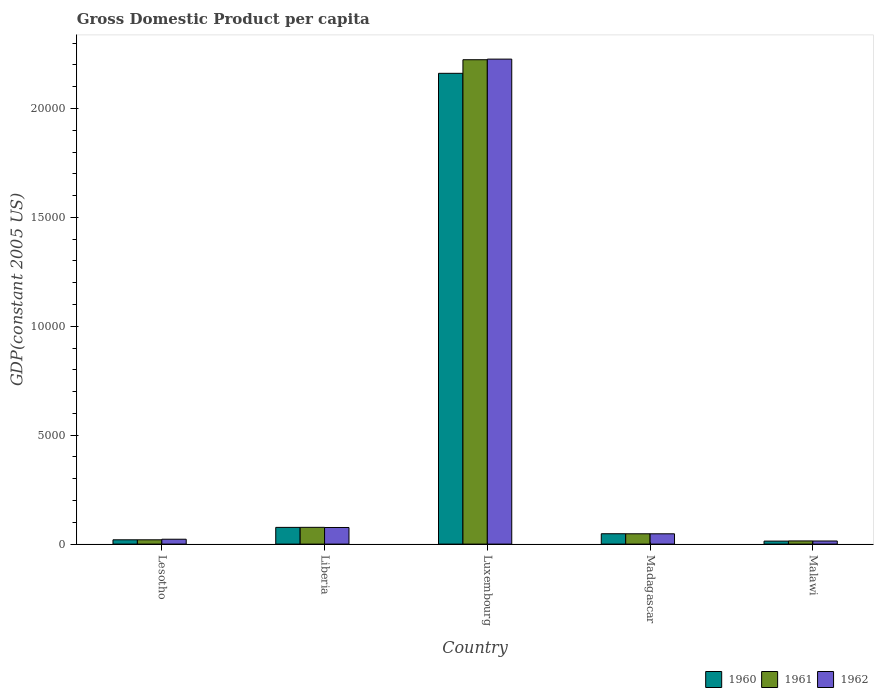How many groups of bars are there?
Ensure brevity in your answer.  5. How many bars are there on the 5th tick from the right?
Offer a terse response. 3. What is the label of the 5th group of bars from the left?
Make the answer very short. Malawi. What is the GDP per capita in 1960 in Malawi?
Offer a very short reply. 138.11. Across all countries, what is the maximum GDP per capita in 1962?
Ensure brevity in your answer.  2.23e+04. Across all countries, what is the minimum GDP per capita in 1960?
Ensure brevity in your answer.  138.11. In which country was the GDP per capita in 1961 maximum?
Your answer should be compact. Luxembourg. In which country was the GDP per capita in 1962 minimum?
Provide a short and direct response. Malawi. What is the total GDP per capita in 1962 in the graph?
Your answer should be very brief. 2.39e+04. What is the difference between the GDP per capita in 1962 in Lesotho and that in Madagascar?
Provide a short and direct response. -248.91. What is the difference between the GDP per capita in 1962 in Lesotho and the GDP per capita in 1961 in Madagascar?
Make the answer very short. -249.83. What is the average GDP per capita in 1962 per country?
Your answer should be compact. 4773.62. What is the difference between the GDP per capita of/in 1961 and GDP per capita of/in 1962 in Madagascar?
Your answer should be very brief. 0.92. In how many countries, is the GDP per capita in 1961 greater than 18000 US$?
Ensure brevity in your answer.  1. What is the ratio of the GDP per capita in 1962 in Madagascar to that in Malawi?
Ensure brevity in your answer.  3.3. Is the difference between the GDP per capita in 1961 in Liberia and Luxembourg greater than the difference between the GDP per capita in 1962 in Liberia and Luxembourg?
Ensure brevity in your answer.  Yes. What is the difference between the highest and the second highest GDP per capita in 1960?
Your answer should be compact. -2.11e+04. What is the difference between the highest and the lowest GDP per capita in 1960?
Ensure brevity in your answer.  2.15e+04. Is the sum of the GDP per capita in 1961 in Liberia and Madagascar greater than the maximum GDP per capita in 1962 across all countries?
Your answer should be very brief. No. Is it the case that in every country, the sum of the GDP per capita in 1962 and GDP per capita in 1960 is greater than the GDP per capita in 1961?
Your response must be concise. Yes. How many countries are there in the graph?
Offer a terse response. 5. Where does the legend appear in the graph?
Keep it short and to the point. Bottom right. How are the legend labels stacked?
Keep it short and to the point. Horizontal. What is the title of the graph?
Ensure brevity in your answer.  Gross Domestic Product per capita. What is the label or title of the Y-axis?
Offer a very short reply. GDP(constant 2005 US). What is the GDP(constant 2005 US) in 1960 in Lesotho?
Your answer should be very brief. 197.38. What is the GDP(constant 2005 US) of 1961 in Lesotho?
Ensure brevity in your answer.  197.61. What is the GDP(constant 2005 US) in 1962 in Lesotho?
Ensure brevity in your answer.  223.86. What is the GDP(constant 2005 US) in 1960 in Liberia?
Offer a very short reply. 767.6. What is the GDP(constant 2005 US) in 1961 in Liberia?
Give a very brief answer. 769.44. What is the GDP(constant 2005 US) in 1962 in Liberia?
Keep it short and to the point. 762.88. What is the GDP(constant 2005 US) of 1960 in Luxembourg?
Your response must be concise. 2.16e+04. What is the GDP(constant 2005 US) in 1961 in Luxembourg?
Your answer should be very brief. 2.22e+04. What is the GDP(constant 2005 US) in 1962 in Luxembourg?
Offer a terse response. 2.23e+04. What is the GDP(constant 2005 US) of 1960 in Madagascar?
Make the answer very short. 475.5. What is the GDP(constant 2005 US) of 1961 in Madagascar?
Provide a short and direct response. 473.7. What is the GDP(constant 2005 US) in 1962 in Madagascar?
Offer a terse response. 472.78. What is the GDP(constant 2005 US) of 1960 in Malawi?
Keep it short and to the point. 138.11. What is the GDP(constant 2005 US) in 1961 in Malawi?
Give a very brief answer. 145.39. What is the GDP(constant 2005 US) in 1962 in Malawi?
Your answer should be compact. 143.1. Across all countries, what is the maximum GDP(constant 2005 US) in 1960?
Offer a very short reply. 2.16e+04. Across all countries, what is the maximum GDP(constant 2005 US) of 1961?
Make the answer very short. 2.22e+04. Across all countries, what is the maximum GDP(constant 2005 US) of 1962?
Provide a short and direct response. 2.23e+04. Across all countries, what is the minimum GDP(constant 2005 US) in 1960?
Offer a terse response. 138.11. Across all countries, what is the minimum GDP(constant 2005 US) of 1961?
Your response must be concise. 145.39. Across all countries, what is the minimum GDP(constant 2005 US) in 1962?
Provide a short and direct response. 143.1. What is the total GDP(constant 2005 US) of 1960 in the graph?
Give a very brief answer. 2.32e+04. What is the total GDP(constant 2005 US) in 1961 in the graph?
Ensure brevity in your answer.  2.38e+04. What is the total GDP(constant 2005 US) of 1962 in the graph?
Ensure brevity in your answer.  2.39e+04. What is the difference between the GDP(constant 2005 US) of 1960 in Lesotho and that in Liberia?
Offer a terse response. -570.22. What is the difference between the GDP(constant 2005 US) of 1961 in Lesotho and that in Liberia?
Offer a terse response. -571.83. What is the difference between the GDP(constant 2005 US) in 1962 in Lesotho and that in Liberia?
Provide a short and direct response. -539.02. What is the difference between the GDP(constant 2005 US) of 1960 in Lesotho and that in Luxembourg?
Your answer should be compact. -2.14e+04. What is the difference between the GDP(constant 2005 US) in 1961 in Lesotho and that in Luxembourg?
Make the answer very short. -2.20e+04. What is the difference between the GDP(constant 2005 US) in 1962 in Lesotho and that in Luxembourg?
Offer a terse response. -2.20e+04. What is the difference between the GDP(constant 2005 US) of 1960 in Lesotho and that in Madagascar?
Make the answer very short. -278.12. What is the difference between the GDP(constant 2005 US) of 1961 in Lesotho and that in Madagascar?
Provide a short and direct response. -276.09. What is the difference between the GDP(constant 2005 US) of 1962 in Lesotho and that in Madagascar?
Offer a terse response. -248.91. What is the difference between the GDP(constant 2005 US) in 1960 in Lesotho and that in Malawi?
Your answer should be very brief. 59.27. What is the difference between the GDP(constant 2005 US) in 1961 in Lesotho and that in Malawi?
Ensure brevity in your answer.  52.22. What is the difference between the GDP(constant 2005 US) in 1962 in Lesotho and that in Malawi?
Offer a terse response. 80.77. What is the difference between the GDP(constant 2005 US) in 1960 in Liberia and that in Luxembourg?
Keep it short and to the point. -2.08e+04. What is the difference between the GDP(constant 2005 US) of 1961 in Liberia and that in Luxembourg?
Ensure brevity in your answer.  -2.15e+04. What is the difference between the GDP(constant 2005 US) in 1962 in Liberia and that in Luxembourg?
Provide a short and direct response. -2.15e+04. What is the difference between the GDP(constant 2005 US) in 1960 in Liberia and that in Madagascar?
Your response must be concise. 292.1. What is the difference between the GDP(constant 2005 US) in 1961 in Liberia and that in Madagascar?
Your answer should be compact. 295.74. What is the difference between the GDP(constant 2005 US) in 1962 in Liberia and that in Madagascar?
Give a very brief answer. 290.11. What is the difference between the GDP(constant 2005 US) in 1960 in Liberia and that in Malawi?
Provide a succinct answer. 629.48. What is the difference between the GDP(constant 2005 US) of 1961 in Liberia and that in Malawi?
Provide a short and direct response. 624.05. What is the difference between the GDP(constant 2005 US) in 1962 in Liberia and that in Malawi?
Your response must be concise. 619.78. What is the difference between the GDP(constant 2005 US) in 1960 in Luxembourg and that in Madagascar?
Your response must be concise. 2.11e+04. What is the difference between the GDP(constant 2005 US) in 1961 in Luxembourg and that in Madagascar?
Provide a succinct answer. 2.18e+04. What is the difference between the GDP(constant 2005 US) in 1962 in Luxembourg and that in Madagascar?
Your response must be concise. 2.18e+04. What is the difference between the GDP(constant 2005 US) of 1960 in Luxembourg and that in Malawi?
Give a very brief answer. 2.15e+04. What is the difference between the GDP(constant 2005 US) in 1961 in Luxembourg and that in Malawi?
Give a very brief answer. 2.21e+04. What is the difference between the GDP(constant 2005 US) of 1962 in Luxembourg and that in Malawi?
Your response must be concise. 2.21e+04. What is the difference between the GDP(constant 2005 US) of 1960 in Madagascar and that in Malawi?
Make the answer very short. 337.39. What is the difference between the GDP(constant 2005 US) of 1961 in Madagascar and that in Malawi?
Your answer should be compact. 328.31. What is the difference between the GDP(constant 2005 US) of 1962 in Madagascar and that in Malawi?
Give a very brief answer. 329.68. What is the difference between the GDP(constant 2005 US) in 1960 in Lesotho and the GDP(constant 2005 US) in 1961 in Liberia?
Provide a short and direct response. -572.07. What is the difference between the GDP(constant 2005 US) of 1960 in Lesotho and the GDP(constant 2005 US) of 1962 in Liberia?
Your response must be concise. -565.51. What is the difference between the GDP(constant 2005 US) of 1961 in Lesotho and the GDP(constant 2005 US) of 1962 in Liberia?
Your answer should be compact. -565.27. What is the difference between the GDP(constant 2005 US) in 1960 in Lesotho and the GDP(constant 2005 US) in 1961 in Luxembourg?
Provide a succinct answer. -2.20e+04. What is the difference between the GDP(constant 2005 US) in 1960 in Lesotho and the GDP(constant 2005 US) in 1962 in Luxembourg?
Keep it short and to the point. -2.21e+04. What is the difference between the GDP(constant 2005 US) of 1961 in Lesotho and the GDP(constant 2005 US) of 1962 in Luxembourg?
Provide a succinct answer. -2.21e+04. What is the difference between the GDP(constant 2005 US) of 1960 in Lesotho and the GDP(constant 2005 US) of 1961 in Madagascar?
Provide a short and direct response. -276.32. What is the difference between the GDP(constant 2005 US) of 1960 in Lesotho and the GDP(constant 2005 US) of 1962 in Madagascar?
Your response must be concise. -275.4. What is the difference between the GDP(constant 2005 US) of 1961 in Lesotho and the GDP(constant 2005 US) of 1962 in Madagascar?
Your response must be concise. -275.16. What is the difference between the GDP(constant 2005 US) of 1960 in Lesotho and the GDP(constant 2005 US) of 1961 in Malawi?
Provide a short and direct response. 51.99. What is the difference between the GDP(constant 2005 US) of 1960 in Lesotho and the GDP(constant 2005 US) of 1962 in Malawi?
Offer a very short reply. 54.28. What is the difference between the GDP(constant 2005 US) of 1961 in Lesotho and the GDP(constant 2005 US) of 1962 in Malawi?
Offer a very short reply. 54.51. What is the difference between the GDP(constant 2005 US) in 1960 in Liberia and the GDP(constant 2005 US) in 1961 in Luxembourg?
Your response must be concise. -2.15e+04. What is the difference between the GDP(constant 2005 US) in 1960 in Liberia and the GDP(constant 2005 US) in 1962 in Luxembourg?
Offer a terse response. -2.15e+04. What is the difference between the GDP(constant 2005 US) of 1961 in Liberia and the GDP(constant 2005 US) of 1962 in Luxembourg?
Your answer should be very brief. -2.15e+04. What is the difference between the GDP(constant 2005 US) of 1960 in Liberia and the GDP(constant 2005 US) of 1961 in Madagascar?
Offer a terse response. 293.9. What is the difference between the GDP(constant 2005 US) of 1960 in Liberia and the GDP(constant 2005 US) of 1962 in Madagascar?
Ensure brevity in your answer.  294.82. What is the difference between the GDP(constant 2005 US) in 1961 in Liberia and the GDP(constant 2005 US) in 1962 in Madagascar?
Provide a succinct answer. 296.67. What is the difference between the GDP(constant 2005 US) of 1960 in Liberia and the GDP(constant 2005 US) of 1961 in Malawi?
Offer a terse response. 622.21. What is the difference between the GDP(constant 2005 US) of 1960 in Liberia and the GDP(constant 2005 US) of 1962 in Malawi?
Your response must be concise. 624.5. What is the difference between the GDP(constant 2005 US) in 1961 in Liberia and the GDP(constant 2005 US) in 1962 in Malawi?
Give a very brief answer. 626.34. What is the difference between the GDP(constant 2005 US) in 1960 in Luxembourg and the GDP(constant 2005 US) in 1961 in Madagascar?
Provide a succinct answer. 2.11e+04. What is the difference between the GDP(constant 2005 US) of 1960 in Luxembourg and the GDP(constant 2005 US) of 1962 in Madagascar?
Give a very brief answer. 2.11e+04. What is the difference between the GDP(constant 2005 US) in 1961 in Luxembourg and the GDP(constant 2005 US) in 1962 in Madagascar?
Make the answer very short. 2.18e+04. What is the difference between the GDP(constant 2005 US) in 1960 in Luxembourg and the GDP(constant 2005 US) in 1961 in Malawi?
Your response must be concise. 2.15e+04. What is the difference between the GDP(constant 2005 US) in 1960 in Luxembourg and the GDP(constant 2005 US) in 1962 in Malawi?
Keep it short and to the point. 2.15e+04. What is the difference between the GDP(constant 2005 US) of 1961 in Luxembourg and the GDP(constant 2005 US) of 1962 in Malawi?
Ensure brevity in your answer.  2.21e+04. What is the difference between the GDP(constant 2005 US) of 1960 in Madagascar and the GDP(constant 2005 US) of 1961 in Malawi?
Offer a very short reply. 330.11. What is the difference between the GDP(constant 2005 US) in 1960 in Madagascar and the GDP(constant 2005 US) in 1962 in Malawi?
Your answer should be very brief. 332.4. What is the difference between the GDP(constant 2005 US) of 1961 in Madagascar and the GDP(constant 2005 US) of 1962 in Malawi?
Offer a terse response. 330.6. What is the average GDP(constant 2005 US) in 1960 per country?
Your response must be concise. 4638.43. What is the average GDP(constant 2005 US) in 1961 per country?
Provide a succinct answer. 4764.78. What is the average GDP(constant 2005 US) of 1962 per country?
Your response must be concise. 4773.62. What is the difference between the GDP(constant 2005 US) of 1960 and GDP(constant 2005 US) of 1961 in Lesotho?
Offer a terse response. -0.24. What is the difference between the GDP(constant 2005 US) of 1960 and GDP(constant 2005 US) of 1962 in Lesotho?
Make the answer very short. -26.49. What is the difference between the GDP(constant 2005 US) in 1961 and GDP(constant 2005 US) in 1962 in Lesotho?
Your response must be concise. -26.25. What is the difference between the GDP(constant 2005 US) in 1960 and GDP(constant 2005 US) in 1961 in Liberia?
Provide a succinct answer. -1.85. What is the difference between the GDP(constant 2005 US) in 1960 and GDP(constant 2005 US) in 1962 in Liberia?
Your answer should be compact. 4.71. What is the difference between the GDP(constant 2005 US) in 1961 and GDP(constant 2005 US) in 1962 in Liberia?
Offer a very short reply. 6.56. What is the difference between the GDP(constant 2005 US) of 1960 and GDP(constant 2005 US) of 1961 in Luxembourg?
Make the answer very short. -624.17. What is the difference between the GDP(constant 2005 US) in 1960 and GDP(constant 2005 US) in 1962 in Luxembourg?
Ensure brevity in your answer.  -651.89. What is the difference between the GDP(constant 2005 US) in 1961 and GDP(constant 2005 US) in 1962 in Luxembourg?
Give a very brief answer. -27.73. What is the difference between the GDP(constant 2005 US) in 1960 and GDP(constant 2005 US) in 1961 in Madagascar?
Provide a succinct answer. 1.8. What is the difference between the GDP(constant 2005 US) in 1960 and GDP(constant 2005 US) in 1962 in Madagascar?
Make the answer very short. 2.72. What is the difference between the GDP(constant 2005 US) of 1961 and GDP(constant 2005 US) of 1962 in Madagascar?
Keep it short and to the point. 0.92. What is the difference between the GDP(constant 2005 US) in 1960 and GDP(constant 2005 US) in 1961 in Malawi?
Provide a succinct answer. -7.28. What is the difference between the GDP(constant 2005 US) in 1960 and GDP(constant 2005 US) in 1962 in Malawi?
Provide a short and direct response. -4.99. What is the difference between the GDP(constant 2005 US) of 1961 and GDP(constant 2005 US) of 1962 in Malawi?
Keep it short and to the point. 2.29. What is the ratio of the GDP(constant 2005 US) of 1960 in Lesotho to that in Liberia?
Your answer should be compact. 0.26. What is the ratio of the GDP(constant 2005 US) in 1961 in Lesotho to that in Liberia?
Give a very brief answer. 0.26. What is the ratio of the GDP(constant 2005 US) of 1962 in Lesotho to that in Liberia?
Offer a terse response. 0.29. What is the ratio of the GDP(constant 2005 US) in 1960 in Lesotho to that in Luxembourg?
Ensure brevity in your answer.  0.01. What is the ratio of the GDP(constant 2005 US) of 1961 in Lesotho to that in Luxembourg?
Provide a succinct answer. 0.01. What is the ratio of the GDP(constant 2005 US) in 1962 in Lesotho to that in Luxembourg?
Make the answer very short. 0.01. What is the ratio of the GDP(constant 2005 US) in 1960 in Lesotho to that in Madagascar?
Give a very brief answer. 0.42. What is the ratio of the GDP(constant 2005 US) in 1961 in Lesotho to that in Madagascar?
Your response must be concise. 0.42. What is the ratio of the GDP(constant 2005 US) of 1962 in Lesotho to that in Madagascar?
Offer a very short reply. 0.47. What is the ratio of the GDP(constant 2005 US) in 1960 in Lesotho to that in Malawi?
Offer a very short reply. 1.43. What is the ratio of the GDP(constant 2005 US) in 1961 in Lesotho to that in Malawi?
Make the answer very short. 1.36. What is the ratio of the GDP(constant 2005 US) in 1962 in Lesotho to that in Malawi?
Offer a very short reply. 1.56. What is the ratio of the GDP(constant 2005 US) of 1960 in Liberia to that in Luxembourg?
Keep it short and to the point. 0.04. What is the ratio of the GDP(constant 2005 US) of 1961 in Liberia to that in Luxembourg?
Your answer should be compact. 0.03. What is the ratio of the GDP(constant 2005 US) of 1962 in Liberia to that in Luxembourg?
Offer a very short reply. 0.03. What is the ratio of the GDP(constant 2005 US) of 1960 in Liberia to that in Madagascar?
Ensure brevity in your answer.  1.61. What is the ratio of the GDP(constant 2005 US) of 1961 in Liberia to that in Madagascar?
Your response must be concise. 1.62. What is the ratio of the GDP(constant 2005 US) in 1962 in Liberia to that in Madagascar?
Make the answer very short. 1.61. What is the ratio of the GDP(constant 2005 US) in 1960 in Liberia to that in Malawi?
Offer a terse response. 5.56. What is the ratio of the GDP(constant 2005 US) in 1961 in Liberia to that in Malawi?
Give a very brief answer. 5.29. What is the ratio of the GDP(constant 2005 US) of 1962 in Liberia to that in Malawi?
Keep it short and to the point. 5.33. What is the ratio of the GDP(constant 2005 US) in 1960 in Luxembourg to that in Madagascar?
Your answer should be compact. 45.45. What is the ratio of the GDP(constant 2005 US) of 1961 in Luxembourg to that in Madagascar?
Give a very brief answer. 46.95. What is the ratio of the GDP(constant 2005 US) in 1962 in Luxembourg to that in Madagascar?
Your answer should be very brief. 47.1. What is the ratio of the GDP(constant 2005 US) of 1960 in Luxembourg to that in Malawi?
Your answer should be compact. 156.49. What is the ratio of the GDP(constant 2005 US) in 1961 in Luxembourg to that in Malawi?
Provide a short and direct response. 152.95. What is the ratio of the GDP(constant 2005 US) of 1962 in Luxembourg to that in Malawi?
Offer a very short reply. 155.6. What is the ratio of the GDP(constant 2005 US) of 1960 in Madagascar to that in Malawi?
Ensure brevity in your answer.  3.44. What is the ratio of the GDP(constant 2005 US) in 1961 in Madagascar to that in Malawi?
Your answer should be very brief. 3.26. What is the ratio of the GDP(constant 2005 US) in 1962 in Madagascar to that in Malawi?
Keep it short and to the point. 3.3. What is the difference between the highest and the second highest GDP(constant 2005 US) in 1960?
Ensure brevity in your answer.  2.08e+04. What is the difference between the highest and the second highest GDP(constant 2005 US) in 1961?
Offer a very short reply. 2.15e+04. What is the difference between the highest and the second highest GDP(constant 2005 US) in 1962?
Provide a succinct answer. 2.15e+04. What is the difference between the highest and the lowest GDP(constant 2005 US) in 1960?
Your response must be concise. 2.15e+04. What is the difference between the highest and the lowest GDP(constant 2005 US) of 1961?
Your response must be concise. 2.21e+04. What is the difference between the highest and the lowest GDP(constant 2005 US) of 1962?
Your response must be concise. 2.21e+04. 